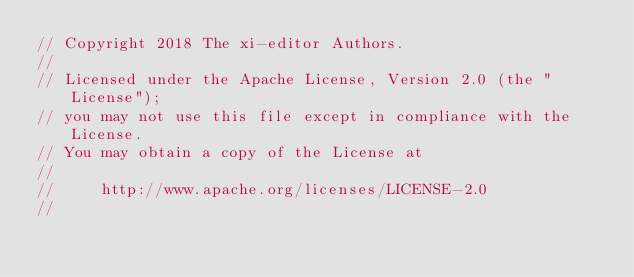<code> <loc_0><loc_0><loc_500><loc_500><_Rust_>// Copyright 2018 The xi-editor Authors.
//
// Licensed under the Apache License, Version 2.0 (the "License");
// you may not use this file except in compliance with the License.
// You may obtain a copy of the License at
//
//     http://www.apache.org/licenses/LICENSE-2.0
//</code> 